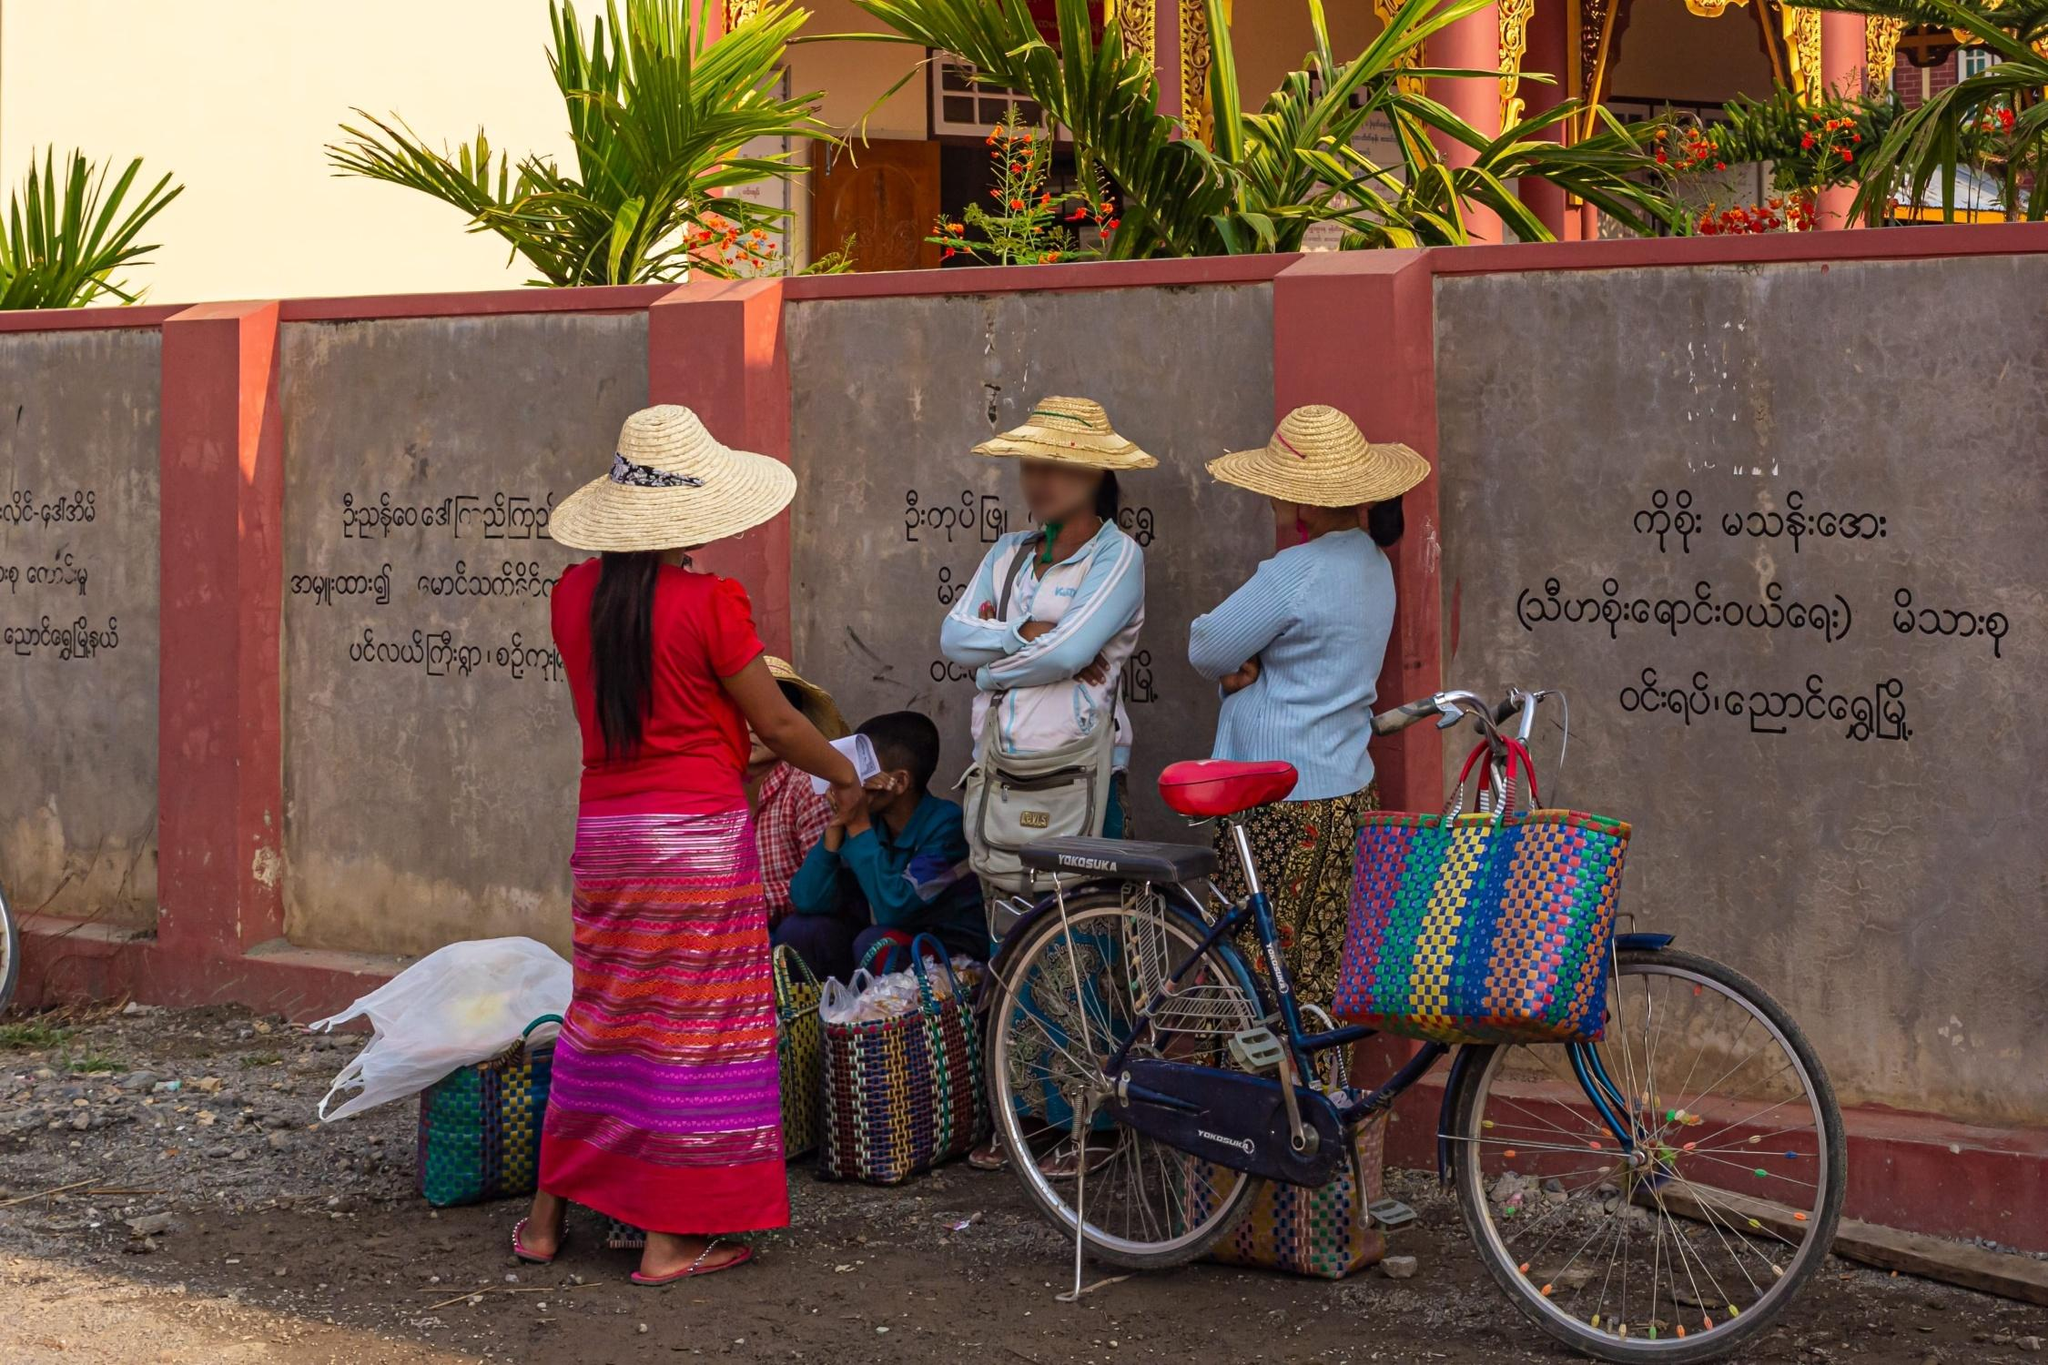Can you tell me more about the significance of the clothing worn by the individuals? The individuals in the image are wearing traditional outfits that suggest cultural heritage. The women's skirts, known as 'longyi', are common in Myanmar and are often brightly colored with intricate patterns. Their blouses are simple yet functional, suitable for the warm climate. The hats, likely made of straw or bamboo, are practical for sun protection but also carry cultural significance, reflecting rural lifestyles and traditional fashions often seen in Southeast Asian countries. 